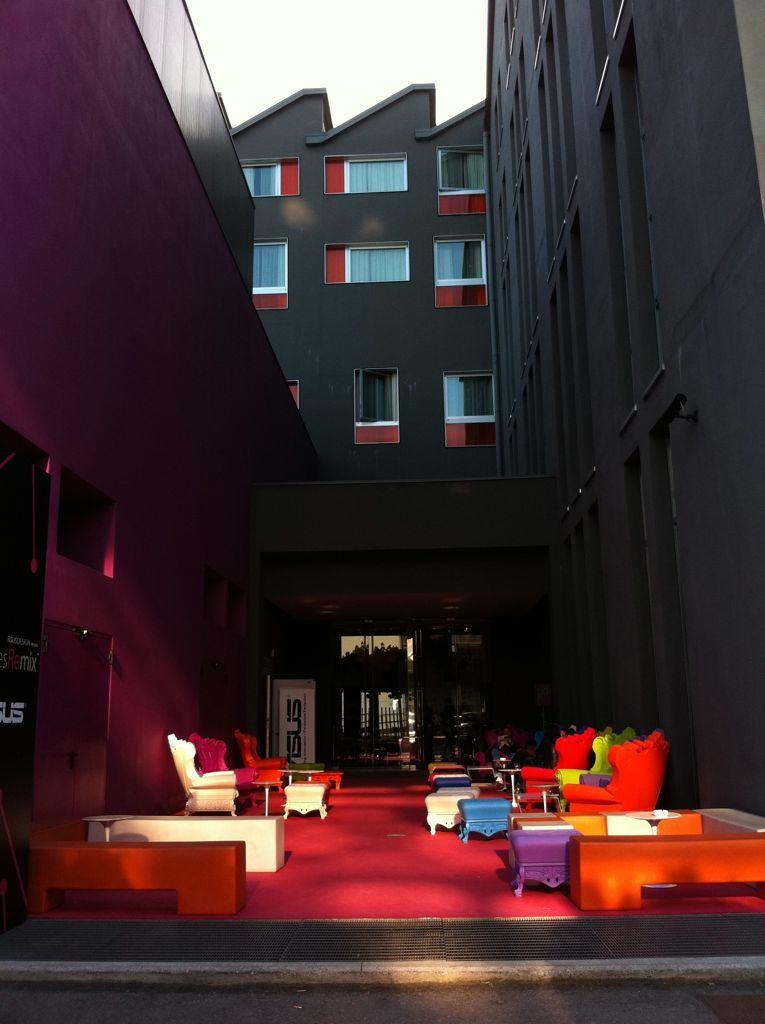What type of structure is visible in the image? There is a building in the image. What objects are located in the middle of the image? There are chairs in the middle of the image. What is visible at the top of the image? The sky is visible at the top of the image. How many girls are drawing with chalk on the apple in the image? There are no girls, chalk, or apple present in the image. 